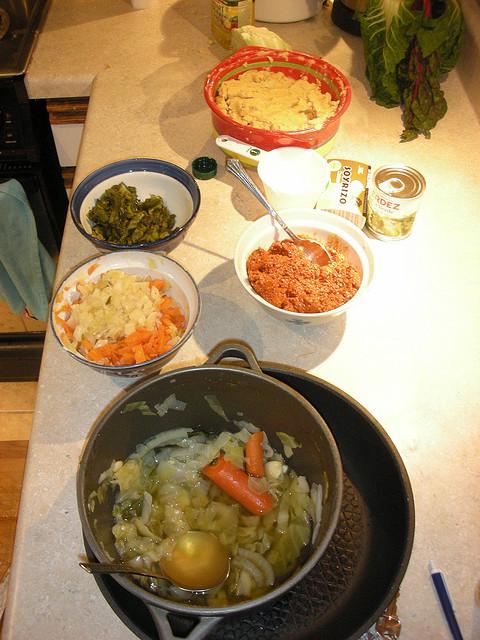What is under the cast iron pan?
Concise answer only. Counter. What color is the spoon in the right top picture?
Keep it brief. Silver. Are the vegetables in the upper right cooked?
Keep it brief. No. How many bowls are in this picture?
Short answer required. 4. What color is the ink pen?
Answer briefly. Blue. Are there more pink or blue packets visible in the picture?
Give a very brief answer. Neither. Is this a healthy dish?
Short answer required. Yes. Is this a healthy breakfast?
Quick response, please. Yes. 